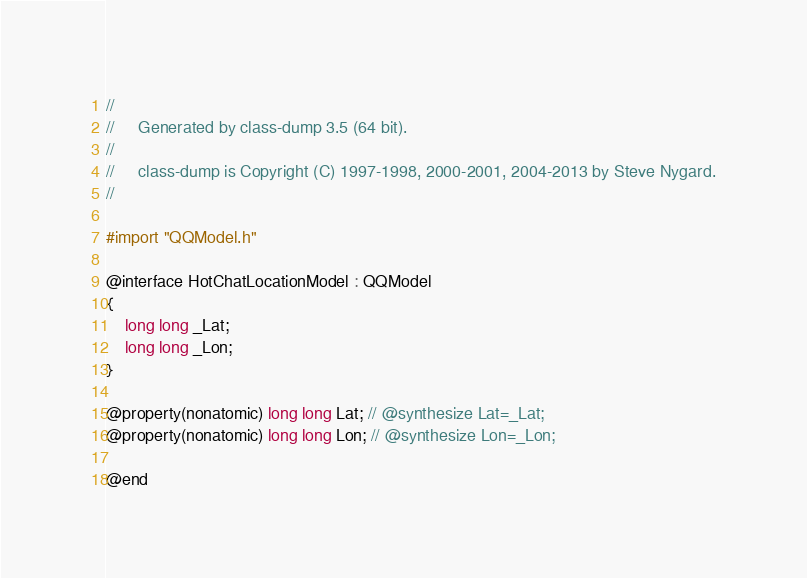<code> <loc_0><loc_0><loc_500><loc_500><_C_>//
//     Generated by class-dump 3.5 (64 bit).
//
//     class-dump is Copyright (C) 1997-1998, 2000-2001, 2004-2013 by Steve Nygard.
//

#import "QQModel.h"

@interface HotChatLocationModel : QQModel
{
    long long _Lat;
    long long _Lon;
}

@property(nonatomic) long long Lat; // @synthesize Lat=_Lat;
@property(nonatomic) long long Lon; // @synthesize Lon=_Lon;

@end

</code> 